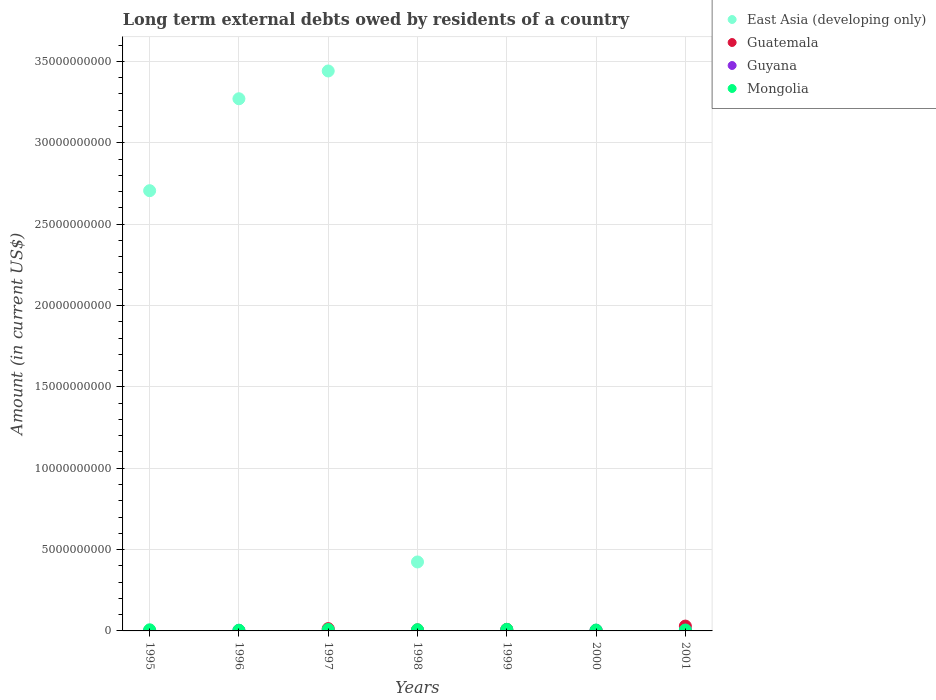Is the number of dotlines equal to the number of legend labels?
Give a very brief answer. No. Across all years, what is the maximum amount of long-term external debts owed by residents in Guyana?
Make the answer very short. 4.57e+07. In which year was the amount of long-term external debts owed by residents in Guyana maximum?
Offer a terse response. 2001. What is the total amount of long-term external debts owed by residents in East Asia (developing only) in the graph?
Provide a short and direct response. 9.85e+1. What is the difference between the amount of long-term external debts owed by residents in Mongolia in 1996 and that in 2001?
Keep it short and to the point. -1.01e+07. What is the difference between the amount of long-term external debts owed by residents in East Asia (developing only) in 1995 and the amount of long-term external debts owed by residents in Guatemala in 2000?
Your answer should be compact. 2.70e+1. What is the average amount of long-term external debts owed by residents in Guyana per year?
Offer a very short reply. 2.28e+07. In the year 1998, what is the difference between the amount of long-term external debts owed by residents in Mongolia and amount of long-term external debts owed by residents in Guyana?
Give a very brief answer. 6.98e+07. In how many years, is the amount of long-term external debts owed by residents in Mongolia greater than 25000000000 US$?
Your answer should be very brief. 0. What is the ratio of the amount of long-term external debts owed by residents in Mongolia in 1997 to that in 1998?
Make the answer very short. 1.17. Is the difference between the amount of long-term external debts owed by residents in Mongolia in 1996 and 1997 greater than the difference between the amount of long-term external debts owed by residents in Guyana in 1996 and 1997?
Keep it short and to the point. No. What is the difference between the highest and the second highest amount of long-term external debts owed by residents in Guyana?
Give a very brief answer. 4.39e+06. What is the difference between the highest and the lowest amount of long-term external debts owed by residents in Guatemala?
Give a very brief answer. 2.99e+08. In how many years, is the amount of long-term external debts owed by residents in Guatemala greater than the average amount of long-term external debts owed by residents in Guatemala taken over all years?
Your response must be concise. 3. How many dotlines are there?
Provide a succinct answer. 4. How many years are there in the graph?
Make the answer very short. 7. What is the difference between two consecutive major ticks on the Y-axis?
Provide a short and direct response. 5.00e+09. Where does the legend appear in the graph?
Keep it short and to the point. Top right. How many legend labels are there?
Provide a succinct answer. 4. What is the title of the graph?
Provide a succinct answer. Long term external debts owed by residents of a country. Does "Bahrain" appear as one of the legend labels in the graph?
Give a very brief answer. No. What is the Amount (in current US$) of East Asia (developing only) in 1995?
Keep it short and to the point. 2.71e+1. What is the Amount (in current US$) of Guatemala in 1995?
Your answer should be very brief. 0. What is the Amount (in current US$) in Mongolia in 1995?
Offer a terse response. 6.84e+07. What is the Amount (in current US$) of East Asia (developing only) in 1996?
Ensure brevity in your answer.  3.27e+1. What is the Amount (in current US$) of Guatemala in 1996?
Keep it short and to the point. 0. What is the Amount (in current US$) of Guyana in 1996?
Your answer should be compact. 3.46e+07. What is the Amount (in current US$) of Mongolia in 1996?
Offer a terse response. 4.43e+07. What is the Amount (in current US$) in East Asia (developing only) in 1997?
Give a very brief answer. 3.44e+1. What is the Amount (in current US$) in Guatemala in 1997?
Your response must be concise. 1.41e+08. What is the Amount (in current US$) of Guyana in 1997?
Offer a very short reply. 1.45e+07. What is the Amount (in current US$) of Mongolia in 1997?
Give a very brief answer. 8.88e+07. What is the Amount (in current US$) of East Asia (developing only) in 1998?
Your response must be concise. 4.24e+09. What is the Amount (in current US$) in Guatemala in 1998?
Your answer should be very brief. 6.37e+07. What is the Amount (in current US$) of Guyana in 1998?
Provide a succinct answer. 5.85e+06. What is the Amount (in current US$) in Mongolia in 1998?
Offer a very short reply. 7.57e+07. What is the Amount (in current US$) of East Asia (developing only) in 1999?
Your answer should be compact. 9.46e+07. What is the Amount (in current US$) in Guatemala in 1999?
Your answer should be very brief. 9.36e+07. What is the Amount (in current US$) of Guyana in 1999?
Make the answer very short. 1.76e+07. What is the Amount (in current US$) in Mongolia in 1999?
Ensure brevity in your answer.  9.83e+07. What is the Amount (in current US$) of Guatemala in 2000?
Offer a very short reply. 2.76e+07. What is the Amount (in current US$) in Guyana in 2000?
Your answer should be very brief. 4.13e+07. What is the Amount (in current US$) in Mongolia in 2000?
Keep it short and to the point. 5.34e+07. What is the Amount (in current US$) in East Asia (developing only) in 2001?
Keep it short and to the point. 0. What is the Amount (in current US$) in Guatemala in 2001?
Offer a terse response. 2.99e+08. What is the Amount (in current US$) in Guyana in 2001?
Your response must be concise. 4.57e+07. What is the Amount (in current US$) of Mongolia in 2001?
Your answer should be very brief. 5.44e+07. Across all years, what is the maximum Amount (in current US$) of East Asia (developing only)?
Your answer should be very brief. 3.44e+1. Across all years, what is the maximum Amount (in current US$) of Guatemala?
Keep it short and to the point. 2.99e+08. Across all years, what is the maximum Amount (in current US$) of Guyana?
Your response must be concise. 4.57e+07. Across all years, what is the maximum Amount (in current US$) in Mongolia?
Provide a short and direct response. 9.83e+07. Across all years, what is the minimum Amount (in current US$) in Guyana?
Provide a short and direct response. 0. Across all years, what is the minimum Amount (in current US$) in Mongolia?
Offer a very short reply. 4.43e+07. What is the total Amount (in current US$) of East Asia (developing only) in the graph?
Offer a very short reply. 9.85e+1. What is the total Amount (in current US$) in Guatemala in the graph?
Provide a succinct answer. 6.24e+08. What is the total Amount (in current US$) of Guyana in the graph?
Offer a terse response. 1.60e+08. What is the total Amount (in current US$) of Mongolia in the graph?
Provide a succinct answer. 4.83e+08. What is the difference between the Amount (in current US$) in East Asia (developing only) in 1995 and that in 1996?
Your answer should be very brief. -5.65e+09. What is the difference between the Amount (in current US$) of Mongolia in 1995 and that in 1996?
Your answer should be compact. 2.41e+07. What is the difference between the Amount (in current US$) of East Asia (developing only) in 1995 and that in 1997?
Provide a short and direct response. -7.36e+09. What is the difference between the Amount (in current US$) in Mongolia in 1995 and that in 1997?
Your response must be concise. -2.04e+07. What is the difference between the Amount (in current US$) in East Asia (developing only) in 1995 and that in 1998?
Your answer should be compact. 2.28e+1. What is the difference between the Amount (in current US$) in Mongolia in 1995 and that in 1998?
Give a very brief answer. -7.26e+06. What is the difference between the Amount (in current US$) of East Asia (developing only) in 1995 and that in 1999?
Offer a terse response. 2.70e+1. What is the difference between the Amount (in current US$) in Mongolia in 1995 and that in 1999?
Your answer should be very brief. -2.99e+07. What is the difference between the Amount (in current US$) of Mongolia in 1995 and that in 2000?
Make the answer very short. 1.50e+07. What is the difference between the Amount (in current US$) in Mongolia in 1995 and that in 2001?
Make the answer very short. 1.40e+07. What is the difference between the Amount (in current US$) of East Asia (developing only) in 1996 and that in 1997?
Your answer should be very brief. -1.71e+09. What is the difference between the Amount (in current US$) of Guyana in 1996 and that in 1997?
Offer a terse response. 2.01e+07. What is the difference between the Amount (in current US$) of Mongolia in 1996 and that in 1997?
Offer a terse response. -4.45e+07. What is the difference between the Amount (in current US$) in East Asia (developing only) in 1996 and that in 1998?
Your response must be concise. 2.85e+1. What is the difference between the Amount (in current US$) in Guyana in 1996 and that in 1998?
Your response must be concise. 2.87e+07. What is the difference between the Amount (in current US$) in Mongolia in 1996 and that in 1998?
Provide a succinct answer. -3.13e+07. What is the difference between the Amount (in current US$) in East Asia (developing only) in 1996 and that in 1999?
Your response must be concise. 3.26e+1. What is the difference between the Amount (in current US$) in Guyana in 1996 and that in 1999?
Keep it short and to the point. 1.70e+07. What is the difference between the Amount (in current US$) in Mongolia in 1996 and that in 1999?
Make the answer very short. -5.40e+07. What is the difference between the Amount (in current US$) of Guyana in 1996 and that in 2000?
Offer a terse response. -6.78e+06. What is the difference between the Amount (in current US$) of Mongolia in 1996 and that in 2000?
Make the answer very short. -9.08e+06. What is the difference between the Amount (in current US$) in Guyana in 1996 and that in 2001?
Your answer should be compact. -1.12e+07. What is the difference between the Amount (in current US$) in Mongolia in 1996 and that in 2001?
Your answer should be very brief. -1.01e+07. What is the difference between the Amount (in current US$) in East Asia (developing only) in 1997 and that in 1998?
Provide a short and direct response. 3.02e+1. What is the difference between the Amount (in current US$) of Guatemala in 1997 and that in 1998?
Your response must be concise. 7.69e+07. What is the difference between the Amount (in current US$) of Guyana in 1997 and that in 1998?
Keep it short and to the point. 8.62e+06. What is the difference between the Amount (in current US$) in Mongolia in 1997 and that in 1998?
Offer a very short reply. 1.32e+07. What is the difference between the Amount (in current US$) in East Asia (developing only) in 1997 and that in 1999?
Ensure brevity in your answer.  3.43e+1. What is the difference between the Amount (in current US$) in Guatemala in 1997 and that in 1999?
Your answer should be very brief. 4.70e+07. What is the difference between the Amount (in current US$) of Guyana in 1997 and that in 1999?
Provide a succinct answer. -3.09e+06. What is the difference between the Amount (in current US$) in Mongolia in 1997 and that in 1999?
Your answer should be very brief. -9.50e+06. What is the difference between the Amount (in current US$) of Guatemala in 1997 and that in 2000?
Provide a short and direct response. 1.13e+08. What is the difference between the Amount (in current US$) of Guyana in 1997 and that in 2000?
Your answer should be very brief. -2.69e+07. What is the difference between the Amount (in current US$) in Mongolia in 1997 and that in 2000?
Keep it short and to the point. 3.54e+07. What is the difference between the Amount (in current US$) in Guatemala in 1997 and that in 2001?
Your answer should be very brief. -1.58e+08. What is the difference between the Amount (in current US$) of Guyana in 1997 and that in 2001?
Ensure brevity in your answer.  -3.13e+07. What is the difference between the Amount (in current US$) of Mongolia in 1997 and that in 2001?
Ensure brevity in your answer.  3.44e+07. What is the difference between the Amount (in current US$) of East Asia (developing only) in 1998 and that in 1999?
Provide a short and direct response. 4.14e+09. What is the difference between the Amount (in current US$) in Guatemala in 1998 and that in 1999?
Your response must be concise. -2.99e+07. What is the difference between the Amount (in current US$) of Guyana in 1998 and that in 1999?
Make the answer very short. -1.17e+07. What is the difference between the Amount (in current US$) in Mongolia in 1998 and that in 1999?
Give a very brief answer. -2.27e+07. What is the difference between the Amount (in current US$) of Guatemala in 1998 and that in 2000?
Offer a terse response. 3.60e+07. What is the difference between the Amount (in current US$) in Guyana in 1998 and that in 2000?
Keep it short and to the point. -3.55e+07. What is the difference between the Amount (in current US$) in Mongolia in 1998 and that in 2000?
Provide a succinct answer. 2.22e+07. What is the difference between the Amount (in current US$) of Guatemala in 1998 and that in 2001?
Give a very brief answer. -2.35e+08. What is the difference between the Amount (in current US$) of Guyana in 1998 and that in 2001?
Keep it short and to the point. -3.99e+07. What is the difference between the Amount (in current US$) of Mongolia in 1998 and that in 2001?
Keep it short and to the point. 2.12e+07. What is the difference between the Amount (in current US$) of Guatemala in 1999 and that in 2000?
Offer a terse response. 6.60e+07. What is the difference between the Amount (in current US$) in Guyana in 1999 and that in 2000?
Give a very brief answer. -2.38e+07. What is the difference between the Amount (in current US$) of Mongolia in 1999 and that in 2000?
Your answer should be compact. 4.49e+07. What is the difference between the Amount (in current US$) in Guatemala in 1999 and that in 2001?
Offer a very short reply. -2.05e+08. What is the difference between the Amount (in current US$) of Guyana in 1999 and that in 2001?
Provide a short and direct response. -2.82e+07. What is the difference between the Amount (in current US$) of Mongolia in 1999 and that in 2001?
Your response must be concise. 4.39e+07. What is the difference between the Amount (in current US$) in Guatemala in 2000 and that in 2001?
Offer a terse response. -2.71e+08. What is the difference between the Amount (in current US$) of Guyana in 2000 and that in 2001?
Provide a short and direct response. -4.39e+06. What is the difference between the Amount (in current US$) in Mongolia in 2000 and that in 2001?
Offer a terse response. -1.01e+06. What is the difference between the Amount (in current US$) of East Asia (developing only) in 1995 and the Amount (in current US$) of Guyana in 1996?
Ensure brevity in your answer.  2.70e+1. What is the difference between the Amount (in current US$) of East Asia (developing only) in 1995 and the Amount (in current US$) of Mongolia in 1996?
Your answer should be compact. 2.70e+1. What is the difference between the Amount (in current US$) of East Asia (developing only) in 1995 and the Amount (in current US$) of Guatemala in 1997?
Provide a succinct answer. 2.69e+1. What is the difference between the Amount (in current US$) in East Asia (developing only) in 1995 and the Amount (in current US$) in Guyana in 1997?
Make the answer very short. 2.70e+1. What is the difference between the Amount (in current US$) in East Asia (developing only) in 1995 and the Amount (in current US$) in Mongolia in 1997?
Keep it short and to the point. 2.70e+1. What is the difference between the Amount (in current US$) of East Asia (developing only) in 1995 and the Amount (in current US$) of Guatemala in 1998?
Ensure brevity in your answer.  2.70e+1. What is the difference between the Amount (in current US$) in East Asia (developing only) in 1995 and the Amount (in current US$) in Guyana in 1998?
Ensure brevity in your answer.  2.71e+1. What is the difference between the Amount (in current US$) in East Asia (developing only) in 1995 and the Amount (in current US$) in Mongolia in 1998?
Offer a very short reply. 2.70e+1. What is the difference between the Amount (in current US$) in East Asia (developing only) in 1995 and the Amount (in current US$) in Guatemala in 1999?
Make the answer very short. 2.70e+1. What is the difference between the Amount (in current US$) of East Asia (developing only) in 1995 and the Amount (in current US$) of Guyana in 1999?
Provide a short and direct response. 2.70e+1. What is the difference between the Amount (in current US$) of East Asia (developing only) in 1995 and the Amount (in current US$) of Mongolia in 1999?
Provide a short and direct response. 2.70e+1. What is the difference between the Amount (in current US$) in East Asia (developing only) in 1995 and the Amount (in current US$) in Guatemala in 2000?
Your answer should be compact. 2.70e+1. What is the difference between the Amount (in current US$) in East Asia (developing only) in 1995 and the Amount (in current US$) in Guyana in 2000?
Ensure brevity in your answer.  2.70e+1. What is the difference between the Amount (in current US$) in East Asia (developing only) in 1995 and the Amount (in current US$) in Mongolia in 2000?
Make the answer very short. 2.70e+1. What is the difference between the Amount (in current US$) of East Asia (developing only) in 1995 and the Amount (in current US$) of Guatemala in 2001?
Make the answer very short. 2.68e+1. What is the difference between the Amount (in current US$) in East Asia (developing only) in 1995 and the Amount (in current US$) in Guyana in 2001?
Offer a terse response. 2.70e+1. What is the difference between the Amount (in current US$) of East Asia (developing only) in 1995 and the Amount (in current US$) of Mongolia in 2001?
Your response must be concise. 2.70e+1. What is the difference between the Amount (in current US$) in East Asia (developing only) in 1996 and the Amount (in current US$) in Guatemala in 1997?
Keep it short and to the point. 3.26e+1. What is the difference between the Amount (in current US$) of East Asia (developing only) in 1996 and the Amount (in current US$) of Guyana in 1997?
Keep it short and to the point. 3.27e+1. What is the difference between the Amount (in current US$) of East Asia (developing only) in 1996 and the Amount (in current US$) of Mongolia in 1997?
Your answer should be compact. 3.26e+1. What is the difference between the Amount (in current US$) of Guyana in 1996 and the Amount (in current US$) of Mongolia in 1997?
Your answer should be very brief. -5.42e+07. What is the difference between the Amount (in current US$) in East Asia (developing only) in 1996 and the Amount (in current US$) in Guatemala in 1998?
Your answer should be very brief. 3.26e+1. What is the difference between the Amount (in current US$) in East Asia (developing only) in 1996 and the Amount (in current US$) in Guyana in 1998?
Your answer should be compact. 3.27e+1. What is the difference between the Amount (in current US$) of East Asia (developing only) in 1996 and the Amount (in current US$) of Mongolia in 1998?
Provide a short and direct response. 3.26e+1. What is the difference between the Amount (in current US$) of Guyana in 1996 and the Amount (in current US$) of Mongolia in 1998?
Provide a succinct answer. -4.11e+07. What is the difference between the Amount (in current US$) of East Asia (developing only) in 1996 and the Amount (in current US$) of Guatemala in 1999?
Give a very brief answer. 3.26e+1. What is the difference between the Amount (in current US$) in East Asia (developing only) in 1996 and the Amount (in current US$) in Guyana in 1999?
Offer a terse response. 3.27e+1. What is the difference between the Amount (in current US$) in East Asia (developing only) in 1996 and the Amount (in current US$) in Mongolia in 1999?
Your answer should be compact. 3.26e+1. What is the difference between the Amount (in current US$) of Guyana in 1996 and the Amount (in current US$) of Mongolia in 1999?
Provide a short and direct response. -6.37e+07. What is the difference between the Amount (in current US$) in East Asia (developing only) in 1996 and the Amount (in current US$) in Guatemala in 2000?
Offer a terse response. 3.27e+1. What is the difference between the Amount (in current US$) in East Asia (developing only) in 1996 and the Amount (in current US$) in Guyana in 2000?
Your response must be concise. 3.27e+1. What is the difference between the Amount (in current US$) in East Asia (developing only) in 1996 and the Amount (in current US$) in Mongolia in 2000?
Ensure brevity in your answer.  3.27e+1. What is the difference between the Amount (in current US$) in Guyana in 1996 and the Amount (in current US$) in Mongolia in 2000?
Offer a terse response. -1.88e+07. What is the difference between the Amount (in current US$) of East Asia (developing only) in 1996 and the Amount (in current US$) of Guatemala in 2001?
Ensure brevity in your answer.  3.24e+1. What is the difference between the Amount (in current US$) in East Asia (developing only) in 1996 and the Amount (in current US$) in Guyana in 2001?
Make the answer very short. 3.27e+1. What is the difference between the Amount (in current US$) in East Asia (developing only) in 1996 and the Amount (in current US$) in Mongolia in 2001?
Provide a succinct answer. 3.27e+1. What is the difference between the Amount (in current US$) in Guyana in 1996 and the Amount (in current US$) in Mongolia in 2001?
Offer a very short reply. -1.99e+07. What is the difference between the Amount (in current US$) in East Asia (developing only) in 1997 and the Amount (in current US$) in Guatemala in 1998?
Make the answer very short. 3.44e+1. What is the difference between the Amount (in current US$) of East Asia (developing only) in 1997 and the Amount (in current US$) of Guyana in 1998?
Give a very brief answer. 3.44e+1. What is the difference between the Amount (in current US$) in East Asia (developing only) in 1997 and the Amount (in current US$) in Mongolia in 1998?
Provide a succinct answer. 3.43e+1. What is the difference between the Amount (in current US$) in Guatemala in 1997 and the Amount (in current US$) in Guyana in 1998?
Provide a short and direct response. 1.35e+08. What is the difference between the Amount (in current US$) of Guatemala in 1997 and the Amount (in current US$) of Mongolia in 1998?
Your response must be concise. 6.49e+07. What is the difference between the Amount (in current US$) of Guyana in 1997 and the Amount (in current US$) of Mongolia in 1998?
Your response must be concise. -6.12e+07. What is the difference between the Amount (in current US$) in East Asia (developing only) in 1997 and the Amount (in current US$) in Guatemala in 1999?
Keep it short and to the point. 3.43e+1. What is the difference between the Amount (in current US$) of East Asia (developing only) in 1997 and the Amount (in current US$) of Guyana in 1999?
Offer a terse response. 3.44e+1. What is the difference between the Amount (in current US$) in East Asia (developing only) in 1997 and the Amount (in current US$) in Mongolia in 1999?
Keep it short and to the point. 3.43e+1. What is the difference between the Amount (in current US$) of Guatemala in 1997 and the Amount (in current US$) of Guyana in 1999?
Your answer should be compact. 1.23e+08. What is the difference between the Amount (in current US$) in Guatemala in 1997 and the Amount (in current US$) in Mongolia in 1999?
Provide a short and direct response. 4.23e+07. What is the difference between the Amount (in current US$) of Guyana in 1997 and the Amount (in current US$) of Mongolia in 1999?
Your answer should be compact. -8.38e+07. What is the difference between the Amount (in current US$) in East Asia (developing only) in 1997 and the Amount (in current US$) in Guatemala in 2000?
Give a very brief answer. 3.44e+1. What is the difference between the Amount (in current US$) in East Asia (developing only) in 1997 and the Amount (in current US$) in Guyana in 2000?
Your answer should be very brief. 3.44e+1. What is the difference between the Amount (in current US$) in East Asia (developing only) in 1997 and the Amount (in current US$) in Mongolia in 2000?
Offer a terse response. 3.44e+1. What is the difference between the Amount (in current US$) in Guatemala in 1997 and the Amount (in current US$) in Guyana in 2000?
Your response must be concise. 9.92e+07. What is the difference between the Amount (in current US$) in Guatemala in 1997 and the Amount (in current US$) in Mongolia in 2000?
Keep it short and to the point. 8.72e+07. What is the difference between the Amount (in current US$) in Guyana in 1997 and the Amount (in current US$) in Mongolia in 2000?
Provide a short and direct response. -3.90e+07. What is the difference between the Amount (in current US$) in East Asia (developing only) in 1997 and the Amount (in current US$) in Guatemala in 2001?
Offer a very short reply. 3.41e+1. What is the difference between the Amount (in current US$) in East Asia (developing only) in 1997 and the Amount (in current US$) in Guyana in 2001?
Your answer should be compact. 3.44e+1. What is the difference between the Amount (in current US$) of East Asia (developing only) in 1997 and the Amount (in current US$) of Mongolia in 2001?
Provide a succinct answer. 3.44e+1. What is the difference between the Amount (in current US$) of Guatemala in 1997 and the Amount (in current US$) of Guyana in 2001?
Ensure brevity in your answer.  9.49e+07. What is the difference between the Amount (in current US$) in Guatemala in 1997 and the Amount (in current US$) in Mongolia in 2001?
Keep it short and to the point. 8.62e+07. What is the difference between the Amount (in current US$) of Guyana in 1997 and the Amount (in current US$) of Mongolia in 2001?
Make the answer very short. -4.00e+07. What is the difference between the Amount (in current US$) of East Asia (developing only) in 1998 and the Amount (in current US$) of Guatemala in 1999?
Your answer should be very brief. 4.14e+09. What is the difference between the Amount (in current US$) of East Asia (developing only) in 1998 and the Amount (in current US$) of Guyana in 1999?
Ensure brevity in your answer.  4.22e+09. What is the difference between the Amount (in current US$) in East Asia (developing only) in 1998 and the Amount (in current US$) in Mongolia in 1999?
Ensure brevity in your answer.  4.14e+09. What is the difference between the Amount (in current US$) in Guatemala in 1998 and the Amount (in current US$) in Guyana in 1999?
Give a very brief answer. 4.61e+07. What is the difference between the Amount (in current US$) in Guatemala in 1998 and the Amount (in current US$) in Mongolia in 1999?
Provide a short and direct response. -3.46e+07. What is the difference between the Amount (in current US$) of Guyana in 1998 and the Amount (in current US$) of Mongolia in 1999?
Your answer should be very brief. -9.25e+07. What is the difference between the Amount (in current US$) of East Asia (developing only) in 1998 and the Amount (in current US$) of Guatemala in 2000?
Provide a short and direct response. 4.21e+09. What is the difference between the Amount (in current US$) of East Asia (developing only) in 1998 and the Amount (in current US$) of Guyana in 2000?
Offer a very short reply. 4.20e+09. What is the difference between the Amount (in current US$) in East Asia (developing only) in 1998 and the Amount (in current US$) in Mongolia in 2000?
Make the answer very short. 4.19e+09. What is the difference between the Amount (in current US$) in Guatemala in 1998 and the Amount (in current US$) in Guyana in 2000?
Make the answer very short. 2.23e+07. What is the difference between the Amount (in current US$) in Guatemala in 1998 and the Amount (in current US$) in Mongolia in 2000?
Provide a short and direct response. 1.03e+07. What is the difference between the Amount (in current US$) in Guyana in 1998 and the Amount (in current US$) in Mongolia in 2000?
Keep it short and to the point. -4.76e+07. What is the difference between the Amount (in current US$) in East Asia (developing only) in 1998 and the Amount (in current US$) in Guatemala in 2001?
Provide a short and direct response. 3.94e+09. What is the difference between the Amount (in current US$) in East Asia (developing only) in 1998 and the Amount (in current US$) in Guyana in 2001?
Ensure brevity in your answer.  4.19e+09. What is the difference between the Amount (in current US$) of East Asia (developing only) in 1998 and the Amount (in current US$) of Mongolia in 2001?
Give a very brief answer. 4.18e+09. What is the difference between the Amount (in current US$) in Guatemala in 1998 and the Amount (in current US$) in Guyana in 2001?
Offer a terse response. 1.79e+07. What is the difference between the Amount (in current US$) of Guatemala in 1998 and the Amount (in current US$) of Mongolia in 2001?
Your answer should be very brief. 9.26e+06. What is the difference between the Amount (in current US$) of Guyana in 1998 and the Amount (in current US$) of Mongolia in 2001?
Keep it short and to the point. -4.86e+07. What is the difference between the Amount (in current US$) of East Asia (developing only) in 1999 and the Amount (in current US$) of Guatemala in 2000?
Offer a very short reply. 6.69e+07. What is the difference between the Amount (in current US$) in East Asia (developing only) in 1999 and the Amount (in current US$) in Guyana in 2000?
Give a very brief answer. 5.32e+07. What is the difference between the Amount (in current US$) in East Asia (developing only) in 1999 and the Amount (in current US$) in Mongolia in 2000?
Keep it short and to the point. 4.11e+07. What is the difference between the Amount (in current US$) in Guatemala in 1999 and the Amount (in current US$) in Guyana in 2000?
Offer a very short reply. 5.23e+07. What is the difference between the Amount (in current US$) in Guatemala in 1999 and the Amount (in current US$) in Mongolia in 2000?
Make the answer very short. 4.02e+07. What is the difference between the Amount (in current US$) of Guyana in 1999 and the Amount (in current US$) of Mongolia in 2000?
Keep it short and to the point. -3.59e+07. What is the difference between the Amount (in current US$) of East Asia (developing only) in 1999 and the Amount (in current US$) of Guatemala in 2001?
Your answer should be very brief. -2.04e+08. What is the difference between the Amount (in current US$) in East Asia (developing only) in 1999 and the Amount (in current US$) in Guyana in 2001?
Your answer should be compact. 4.88e+07. What is the difference between the Amount (in current US$) of East Asia (developing only) in 1999 and the Amount (in current US$) of Mongolia in 2001?
Offer a very short reply. 4.01e+07. What is the difference between the Amount (in current US$) of Guatemala in 1999 and the Amount (in current US$) of Guyana in 2001?
Your answer should be compact. 4.79e+07. What is the difference between the Amount (in current US$) in Guatemala in 1999 and the Amount (in current US$) in Mongolia in 2001?
Provide a short and direct response. 3.92e+07. What is the difference between the Amount (in current US$) in Guyana in 1999 and the Amount (in current US$) in Mongolia in 2001?
Offer a very short reply. -3.69e+07. What is the difference between the Amount (in current US$) of Guatemala in 2000 and the Amount (in current US$) of Guyana in 2001?
Your answer should be compact. -1.81e+07. What is the difference between the Amount (in current US$) in Guatemala in 2000 and the Amount (in current US$) in Mongolia in 2001?
Offer a terse response. -2.68e+07. What is the difference between the Amount (in current US$) in Guyana in 2000 and the Amount (in current US$) in Mongolia in 2001?
Provide a short and direct response. -1.31e+07. What is the average Amount (in current US$) of East Asia (developing only) per year?
Your response must be concise. 1.41e+1. What is the average Amount (in current US$) in Guatemala per year?
Your response must be concise. 8.92e+07. What is the average Amount (in current US$) of Guyana per year?
Your response must be concise. 2.28e+07. What is the average Amount (in current US$) of Mongolia per year?
Give a very brief answer. 6.91e+07. In the year 1995, what is the difference between the Amount (in current US$) in East Asia (developing only) and Amount (in current US$) in Mongolia?
Provide a succinct answer. 2.70e+1. In the year 1996, what is the difference between the Amount (in current US$) in East Asia (developing only) and Amount (in current US$) in Guyana?
Provide a succinct answer. 3.27e+1. In the year 1996, what is the difference between the Amount (in current US$) in East Asia (developing only) and Amount (in current US$) in Mongolia?
Give a very brief answer. 3.27e+1. In the year 1996, what is the difference between the Amount (in current US$) of Guyana and Amount (in current US$) of Mongolia?
Your answer should be very brief. -9.77e+06. In the year 1997, what is the difference between the Amount (in current US$) in East Asia (developing only) and Amount (in current US$) in Guatemala?
Provide a short and direct response. 3.43e+1. In the year 1997, what is the difference between the Amount (in current US$) in East Asia (developing only) and Amount (in current US$) in Guyana?
Your response must be concise. 3.44e+1. In the year 1997, what is the difference between the Amount (in current US$) in East Asia (developing only) and Amount (in current US$) in Mongolia?
Offer a very short reply. 3.43e+1. In the year 1997, what is the difference between the Amount (in current US$) in Guatemala and Amount (in current US$) in Guyana?
Provide a succinct answer. 1.26e+08. In the year 1997, what is the difference between the Amount (in current US$) in Guatemala and Amount (in current US$) in Mongolia?
Offer a terse response. 5.18e+07. In the year 1997, what is the difference between the Amount (in current US$) of Guyana and Amount (in current US$) of Mongolia?
Make the answer very short. -7.44e+07. In the year 1998, what is the difference between the Amount (in current US$) in East Asia (developing only) and Amount (in current US$) in Guatemala?
Provide a short and direct response. 4.17e+09. In the year 1998, what is the difference between the Amount (in current US$) of East Asia (developing only) and Amount (in current US$) of Guyana?
Offer a terse response. 4.23e+09. In the year 1998, what is the difference between the Amount (in current US$) of East Asia (developing only) and Amount (in current US$) of Mongolia?
Your response must be concise. 4.16e+09. In the year 1998, what is the difference between the Amount (in current US$) in Guatemala and Amount (in current US$) in Guyana?
Offer a very short reply. 5.78e+07. In the year 1998, what is the difference between the Amount (in current US$) in Guatemala and Amount (in current US$) in Mongolia?
Give a very brief answer. -1.20e+07. In the year 1998, what is the difference between the Amount (in current US$) in Guyana and Amount (in current US$) in Mongolia?
Ensure brevity in your answer.  -6.98e+07. In the year 1999, what is the difference between the Amount (in current US$) of East Asia (developing only) and Amount (in current US$) of Guatemala?
Ensure brevity in your answer.  9.51e+05. In the year 1999, what is the difference between the Amount (in current US$) of East Asia (developing only) and Amount (in current US$) of Guyana?
Give a very brief answer. 7.70e+07. In the year 1999, what is the difference between the Amount (in current US$) in East Asia (developing only) and Amount (in current US$) in Mongolia?
Your response must be concise. -3.75e+06. In the year 1999, what is the difference between the Amount (in current US$) of Guatemala and Amount (in current US$) of Guyana?
Ensure brevity in your answer.  7.61e+07. In the year 1999, what is the difference between the Amount (in current US$) in Guatemala and Amount (in current US$) in Mongolia?
Make the answer very short. -4.70e+06. In the year 1999, what is the difference between the Amount (in current US$) in Guyana and Amount (in current US$) in Mongolia?
Give a very brief answer. -8.08e+07. In the year 2000, what is the difference between the Amount (in current US$) of Guatemala and Amount (in current US$) of Guyana?
Offer a very short reply. -1.37e+07. In the year 2000, what is the difference between the Amount (in current US$) of Guatemala and Amount (in current US$) of Mongolia?
Your answer should be compact. -2.58e+07. In the year 2000, what is the difference between the Amount (in current US$) in Guyana and Amount (in current US$) in Mongolia?
Keep it short and to the point. -1.21e+07. In the year 2001, what is the difference between the Amount (in current US$) in Guatemala and Amount (in current US$) in Guyana?
Ensure brevity in your answer.  2.53e+08. In the year 2001, what is the difference between the Amount (in current US$) of Guatemala and Amount (in current US$) of Mongolia?
Keep it short and to the point. 2.44e+08. In the year 2001, what is the difference between the Amount (in current US$) of Guyana and Amount (in current US$) of Mongolia?
Your answer should be compact. -8.69e+06. What is the ratio of the Amount (in current US$) in East Asia (developing only) in 1995 to that in 1996?
Your answer should be compact. 0.83. What is the ratio of the Amount (in current US$) in Mongolia in 1995 to that in 1996?
Your answer should be compact. 1.54. What is the ratio of the Amount (in current US$) in East Asia (developing only) in 1995 to that in 1997?
Your answer should be compact. 0.79. What is the ratio of the Amount (in current US$) in Mongolia in 1995 to that in 1997?
Offer a terse response. 0.77. What is the ratio of the Amount (in current US$) in East Asia (developing only) in 1995 to that in 1998?
Your response must be concise. 6.38. What is the ratio of the Amount (in current US$) in Mongolia in 1995 to that in 1998?
Offer a terse response. 0.9. What is the ratio of the Amount (in current US$) of East Asia (developing only) in 1995 to that in 1999?
Provide a succinct answer. 286.13. What is the ratio of the Amount (in current US$) in Mongolia in 1995 to that in 1999?
Offer a terse response. 0.7. What is the ratio of the Amount (in current US$) of Mongolia in 1995 to that in 2000?
Offer a terse response. 1.28. What is the ratio of the Amount (in current US$) in Mongolia in 1995 to that in 2001?
Provide a short and direct response. 1.26. What is the ratio of the Amount (in current US$) of East Asia (developing only) in 1996 to that in 1997?
Keep it short and to the point. 0.95. What is the ratio of the Amount (in current US$) in Guyana in 1996 to that in 1997?
Keep it short and to the point. 2.39. What is the ratio of the Amount (in current US$) of Mongolia in 1996 to that in 1997?
Make the answer very short. 0.5. What is the ratio of the Amount (in current US$) of East Asia (developing only) in 1996 to that in 1998?
Your answer should be very brief. 7.72. What is the ratio of the Amount (in current US$) of Guyana in 1996 to that in 1998?
Provide a succinct answer. 5.91. What is the ratio of the Amount (in current US$) of Mongolia in 1996 to that in 1998?
Offer a very short reply. 0.59. What is the ratio of the Amount (in current US$) of East Asia (developing only) in 1996 to that in 1999?
Your answer should be compact. 345.89. What is the ratio of the Amount (in current US$) of Guyana in 1996 to that in 1999?
Keep it short and to the point. 1.97. What is the ratio of the Amount (in current US$) in Mongolia in 1996 to that in 1999?
Make the answer very short. 0.45. What is the ratio of the Amount (in current US$) in Guyana in 1996 to that in 2000?
Offer a very short reply. 0.84. What is the ratio of the Amount (in current US$) of Mongolia in 1996 to that in 2000?
Provide a short and direct response. 0.83. What is the ratio of the Amount (in current US$) in Guyana in 1996 to that in 2001?
Offer a terse response. 0.76. What is the ratio of the Amount (in current US$) of Mongolia in 1996 to that in 2001?
Ensure brevity in your answer.  0.81. What is the ratio of the Amount (in current US$) of East Asia (developing only) in 1997 to that in 1998?
Give a very brief answer. 8.12. What is the ratio of the Amount (in current US$) of Guatemala in 1997 to that in 1998?
Make the answer very short. 2.21. What is the ratio of the Amount (in current US$) in Guyana in 1997 to that in 1998?
Provide a succinct answer. 2.47. What is the ratio of the Amount (in current US$) of Mongolia in 1997 to that in 1998?
Your answer should be compact. 1.17. What is the ratio of the Amount (in current US$) of East Asia (developing only) in 1997 to that in 1999?
Offer a very short reply. 363.94. What is the ratio of the Amount (in current US$) in Guatemala in 1997 to that in 1999?
Your answer should be compact. 1.5. What is the ratio of the Amount (in current US$) of Guyana in 1997 to that in 1999?
Keep it short and to the point. 0.82. What is the ratio of the Amount (in current US$) of Mongolia in 1997 to that in 1999?
Give a very brief answer. 0.9. What is the ratio of the Amount (in current US$) in Guatemala in 1997 to that in 2000?
Keep it short and to the point. 5.09. What is the ratio of the Amount (in current US$) of Guyana in 1997 to that in 2000?
Your response must be concise. 0.35. What is the ratio of the Amount (in current US$) of Mongolia in 1997 to that in 2000?
Offer a terse response. 1.66. What is the ratio of the Amount (in current US$) of Guatemala in 1997 to that in 2001?
Keep it short and to the point. 0.47. What is the ratio of the Amount (in current US$) in Guyana in 1997 to that in 2001?
Make the answer very short. 0.32. What is the ratio of the Amount (in current US$) of Mongolia in 1997 to that in 2001?
Provide a short and direct response. 1.63. What is the ratio of the Amount (in current US$) in East Asia (developing only) in 1998 to that in 1999?
Give a very brief answer. 44.82. What is the ratio of the Amount (in current US$) of Guatemala in 1998 to that in 1999?
Provide a short and direct response. 0.68. What is the ratio of the Amount (in current US$) in Guyana in 1998 to that in 1999?
Keep it short and to the point. 0.33. What is the ratio of the Amount (in current US$) in Mongolia in 1998 to that in 1999?
Provide a short and direct response. 0.77. What is the ratio of the Amount (in current US$) of Guatemala in 1998 to that in 2000?
Offer a very short reply. 2.3. What is the ratio of the Amount (in current US$) of Guyana in 1998 to that in 2000?
Offer a very short reply. 0.14. What is the ratio of the Amount (in current US$) in Mongolia in 1998 to that in 2000?
Offer a terse response. 1.42. What is the ratio of the Amount (in current US$) in Guatemala in 1998 to that in 2001?
Your answer should be very brief. 0.21. What is the ratio of the Amount (in current US$) of Guyana in 1998 to that in 2001?
Give a very brief answer. 0.13. What is the ratio of the Amount (in current US$) in Mongolia in 1998 to that in 2001?
Provide a succinct answer. 1.39. What is the ratio of the Amount (in current US$) in Guatemala in 1999 to that in 2000?
Your answer should be very brief. 3.39. What is the ratio of the Amount (in current US$) of Guyana in 1999 to that in 2000?
Offer a terse response. 0.42. What is the ratio of the Amount (in current US$) of Mongolia in 1999 to that in 2000?
Keep it short and to the point. 1.84. What is the ratio of the Amount (in current US$) in Guatemala in 1999 to that in 2001?
Offer a very short reply. 0.31. What is the ratio of the Amount (in current US$) of Guyana in 1999 to that in 2001?
Give a very brief answer. 0.38. What is the ratio of the Amount (in current US$) in Mongolia in 1999 to that in 2001?
Your response must be concise. 1.81. What is the ratio of the Amount (in current US$) of Guatemala in 2000 to that in 2001?
Keep it short and to the point. 0.09. What is the ratio of the Amount (in current US$) of Guyana in 2000 to that in 2001?
Provide a short and direct response. 0.9. What is the ratio of the Amount (in current US$) in Mongolia in 2000 to that in 2001?
Provide a succinct answer. 0.98. What is the difference between the highest and the second highest Amount (in current US$) of East Asia (developing only)?
Your answer should be compact. 1.71e+09. What is the difference between the highest and the second highest Amount (in current US$) of Guatemala?
Offer a terse response. 1.58e+08. What is the difference between the highest and the second highest Amount (in current US$) in Guyana?
Offer a very short reply. 4.39e+06. What is the difference between the highest and the second highest Amount (in current US$) of Mongolia?
Provide a short and direct response. 9.50e+06. What is the difference between the highest and the lowest Amount (in current US$) of East Asia (developing only)?
Offer a terse response. 3.44e+1. What is the difference between the highest and the lowest Amount (in current US$) of Guatemala?
Offer a terse response. 2.99e+08. What is the difference between the highest and the lowest Amount (in current US$) in Guyana?
Your answer should be compact. 4.57e+07. What is the difference between the highest and the lowest Amount (in current US$) in Mongolia?
Provide a succinct answer. 5.40e+07. 